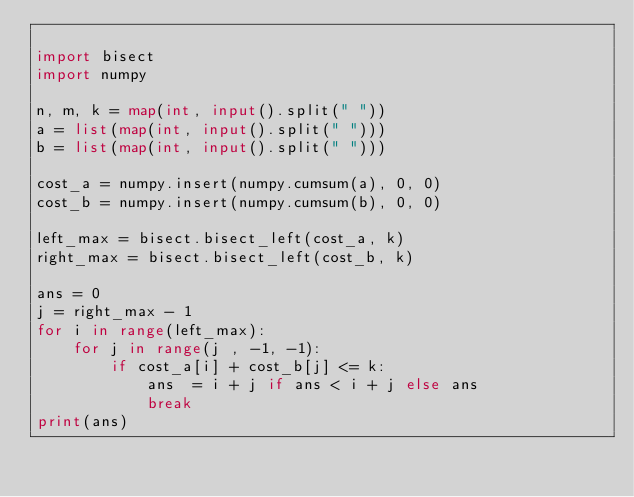<code> <loc_0><loc_0><loc_500><loc_500><_Python_>
import bisect
import numpy

n, m, k = map(int, input().split(" "))
a = list(map(int, input().split(" ")))
b = list(map(int, input().split(" ")))

cost_a = numpy.insert(numpy.cumsum(a), 0, 0)
cost_b = numpy.insert(numpy.cumsum(b), 0, 0)

left_max = bisect.bisect_left(cost_a, k)
right_max = bisect.bisect_left(cost_b, k)

ans = 0
j = right_max - 1
for i in range(left_max):
    for j in range(j , -1, -1):
        if cost_a[i] + cost_b[j] <= k:
            ans  = i + j if ans < i + j else ans
            break
print(ans)</code> 